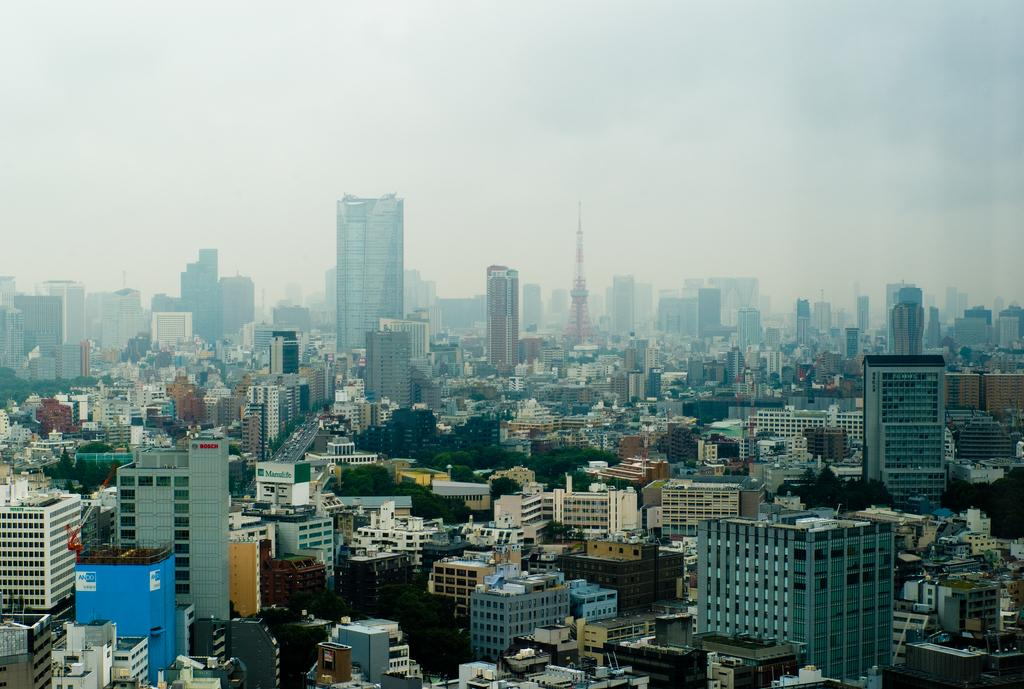What type of location is depicted in the image? The image is of a city. What structures can be seen in the city? There are buildings in the image. What mode of transportation is present in the image? There are vehicles on the road in the image. What part of the natural environment is visible in the image? The sky is visible in the image. What type of jewel can be seen embedded in the floor of the city in the image? There is no jewel present in the image, nor is there any mention of a floor in the provided facts. 